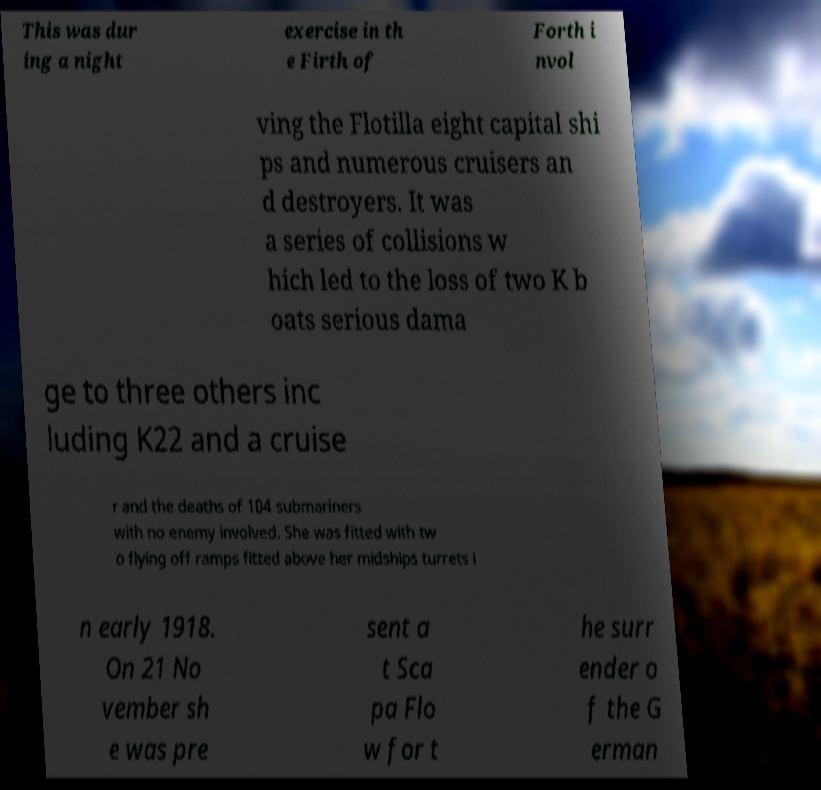Could you assist in decoding the text presented in this image and type it out clearly? This was dur ing a night exercise in th e Firth of Forth i nvol ving the Flotilla eight capital shi ps and numerous cruisers an d destroyers. It was a series of collisions w hich led to the loss of two K b oats serious dama ge to three others inc luding K22 and a cruise r and the deaths of 104 submariners with no enemy involved. She was fitted with tw o flying off ramps fitted above her midships turrets i n early 1918. On 21 No vember sh e was pre sent a t Sca pa Flo w for t he surr ender o f the G erman 